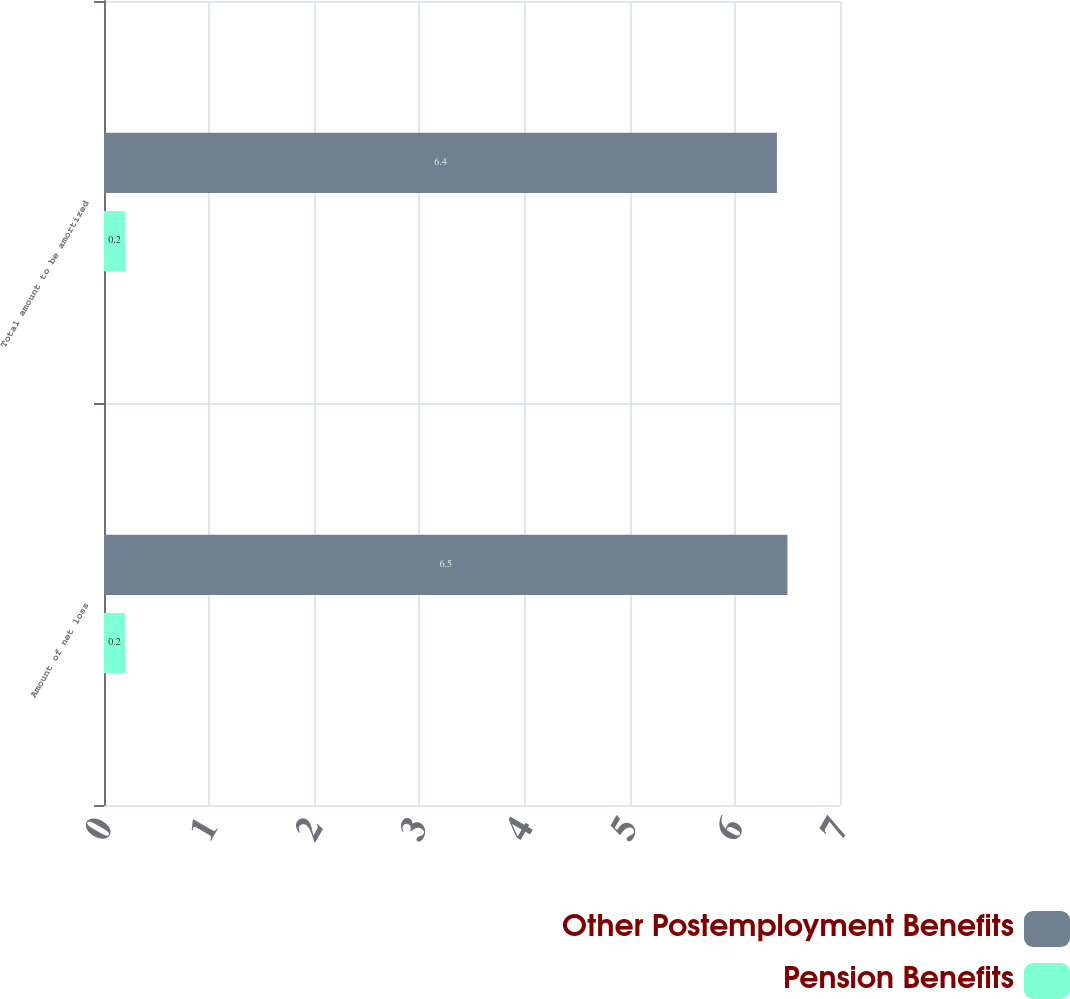Convert chart. <chart><loc_0><loc_0><loc_500><loc_500><stacked_bar_chart><ecel><fcel>Amount of net loss<fcel>Total amount to be amortized<nl><fcel>Other Postemployment Benefits<fcel>6.5<fcel>6.4<nl><fcel>Pension Benefits<fcel>0.2<fcel>0.2<nl></chart> 